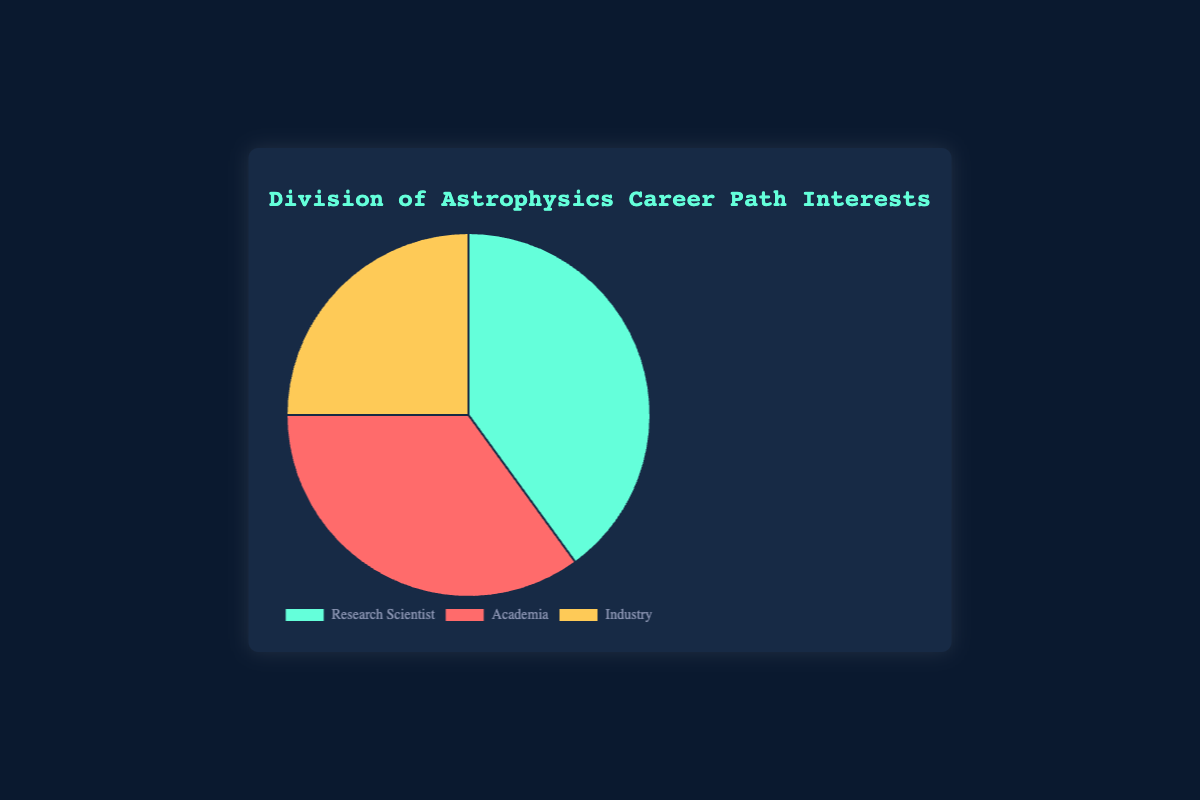What is the most popular career path choice? The slice for "Research Scientist" has the highest percentage in the pie chart at 40%.
Answer: Research Scientist Which career path has the smallest interest percentage? The slice for "Industry" is the smallest, showing 25%.
Answer: Industry By how much percentage does the interest in "Research Scientist" exceed "Industry"? Research Scientist has 40% and Industry has 25%, so the difference is 40 - 25 = 15%.
Answer: 15% What is the total percentage of people interested in either "Research Scientist" or "Academia"? Sum the percentages of Research Scientist (40%) and Academia (35%): 40 + 35 = 75%.
Answer: 75% Which two career paths combined make up more than half of the total interest? The combined interest of Research Scientist (40%) and Academia (35%) is 40 + 35 = 75%, which is greater than 50%.
Answer: Research Scientist and Academia What is the fraction of interest in "Industry" as compared to "Research Scientist"? The interest in Industry (25%) compared to Research Scientist (40%) can be expressed as a fraction: 25/40, which simplifies to 5/8.
Answer: 5/8 If you were to color-code the pie chart, what colors represent "Academia"? The slice for "Academia" is colored red.
Answer: Red How much less interest is there in "Academia" compared to "Research Scientist"? Research Scientist has 40% interest and Academia has 35% interest, the difference is 40 - 35 = 5%.
Answer: 5% How evenly is the interest distributed among the three career paths? The percentages are 40% for Research Scientist, 35% for Academia, and 25% for Industry.
Answer: Not evenly distributed; Research Scientist has the highest, followed by Academia, then Industry If the total number of students surveyed is 100, how many are interested in "Industry"? If the total percentage is 100% and Industry represents 25%, then 25% of 100 is 25 students.
Answer: 25 students 